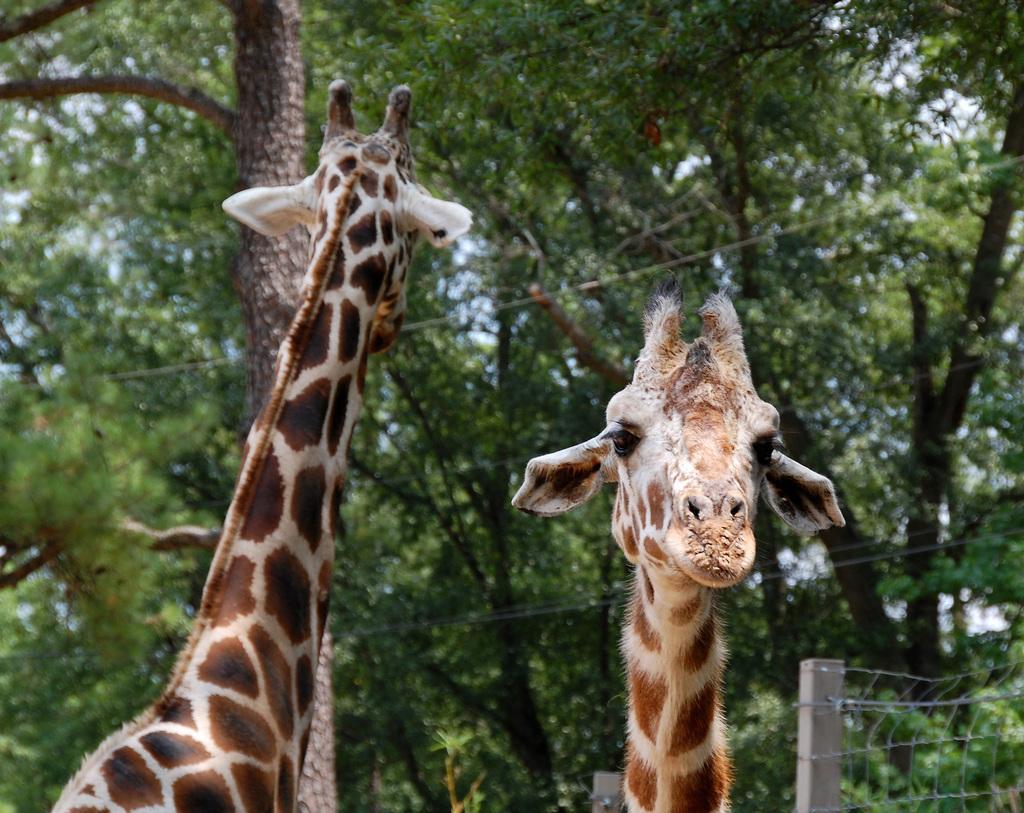Could you give a brief overview of what you see in this image? In this picture I can see two giraffes. I can see trees in the background. I can see the metal grill fence on the right side. 